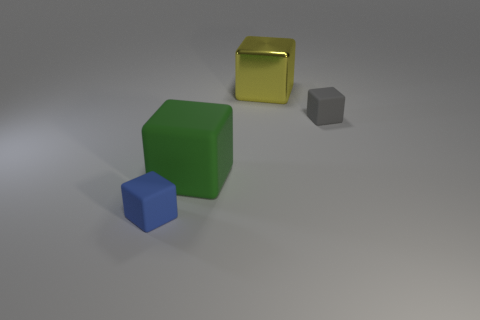There is a tiny matte object left of the tiny block right of the green matte object; what number of tiny rubber things are right of it?
Keep it short and to the point. 1. What is the color of the cube that is both on the left side of the tiny gray cube and behind the big green thing?
Offer a very short reply. Yellow. How many big matte blocks have the same color as the big metal thing?
Provide a short and direct response. 0. What number of blocks are either small brown metal things or green things?
Keep it short and to the point. 1. There is another cube that is the same size as the green block; what is its color?
Your answer should be compact. Yellow. There is a big object that is in front of the tiny rubber cube that is to the right of the green object; are there any green rubber blocks behind it?
Make the answer very short. No. What is the size of the gray block?
Keep it short and to the point. Small. What number of things are either yellow cylinders or small gray objects?
Make the answer very short. 1. The small cube that is the same material as the gray object is what color?
Provide a succinct answer. Blue. Does the rubber thing that is behind the large rubber thing have the same shape as the small blue matte object?
Ensure brevity in your answer.  Yes. 